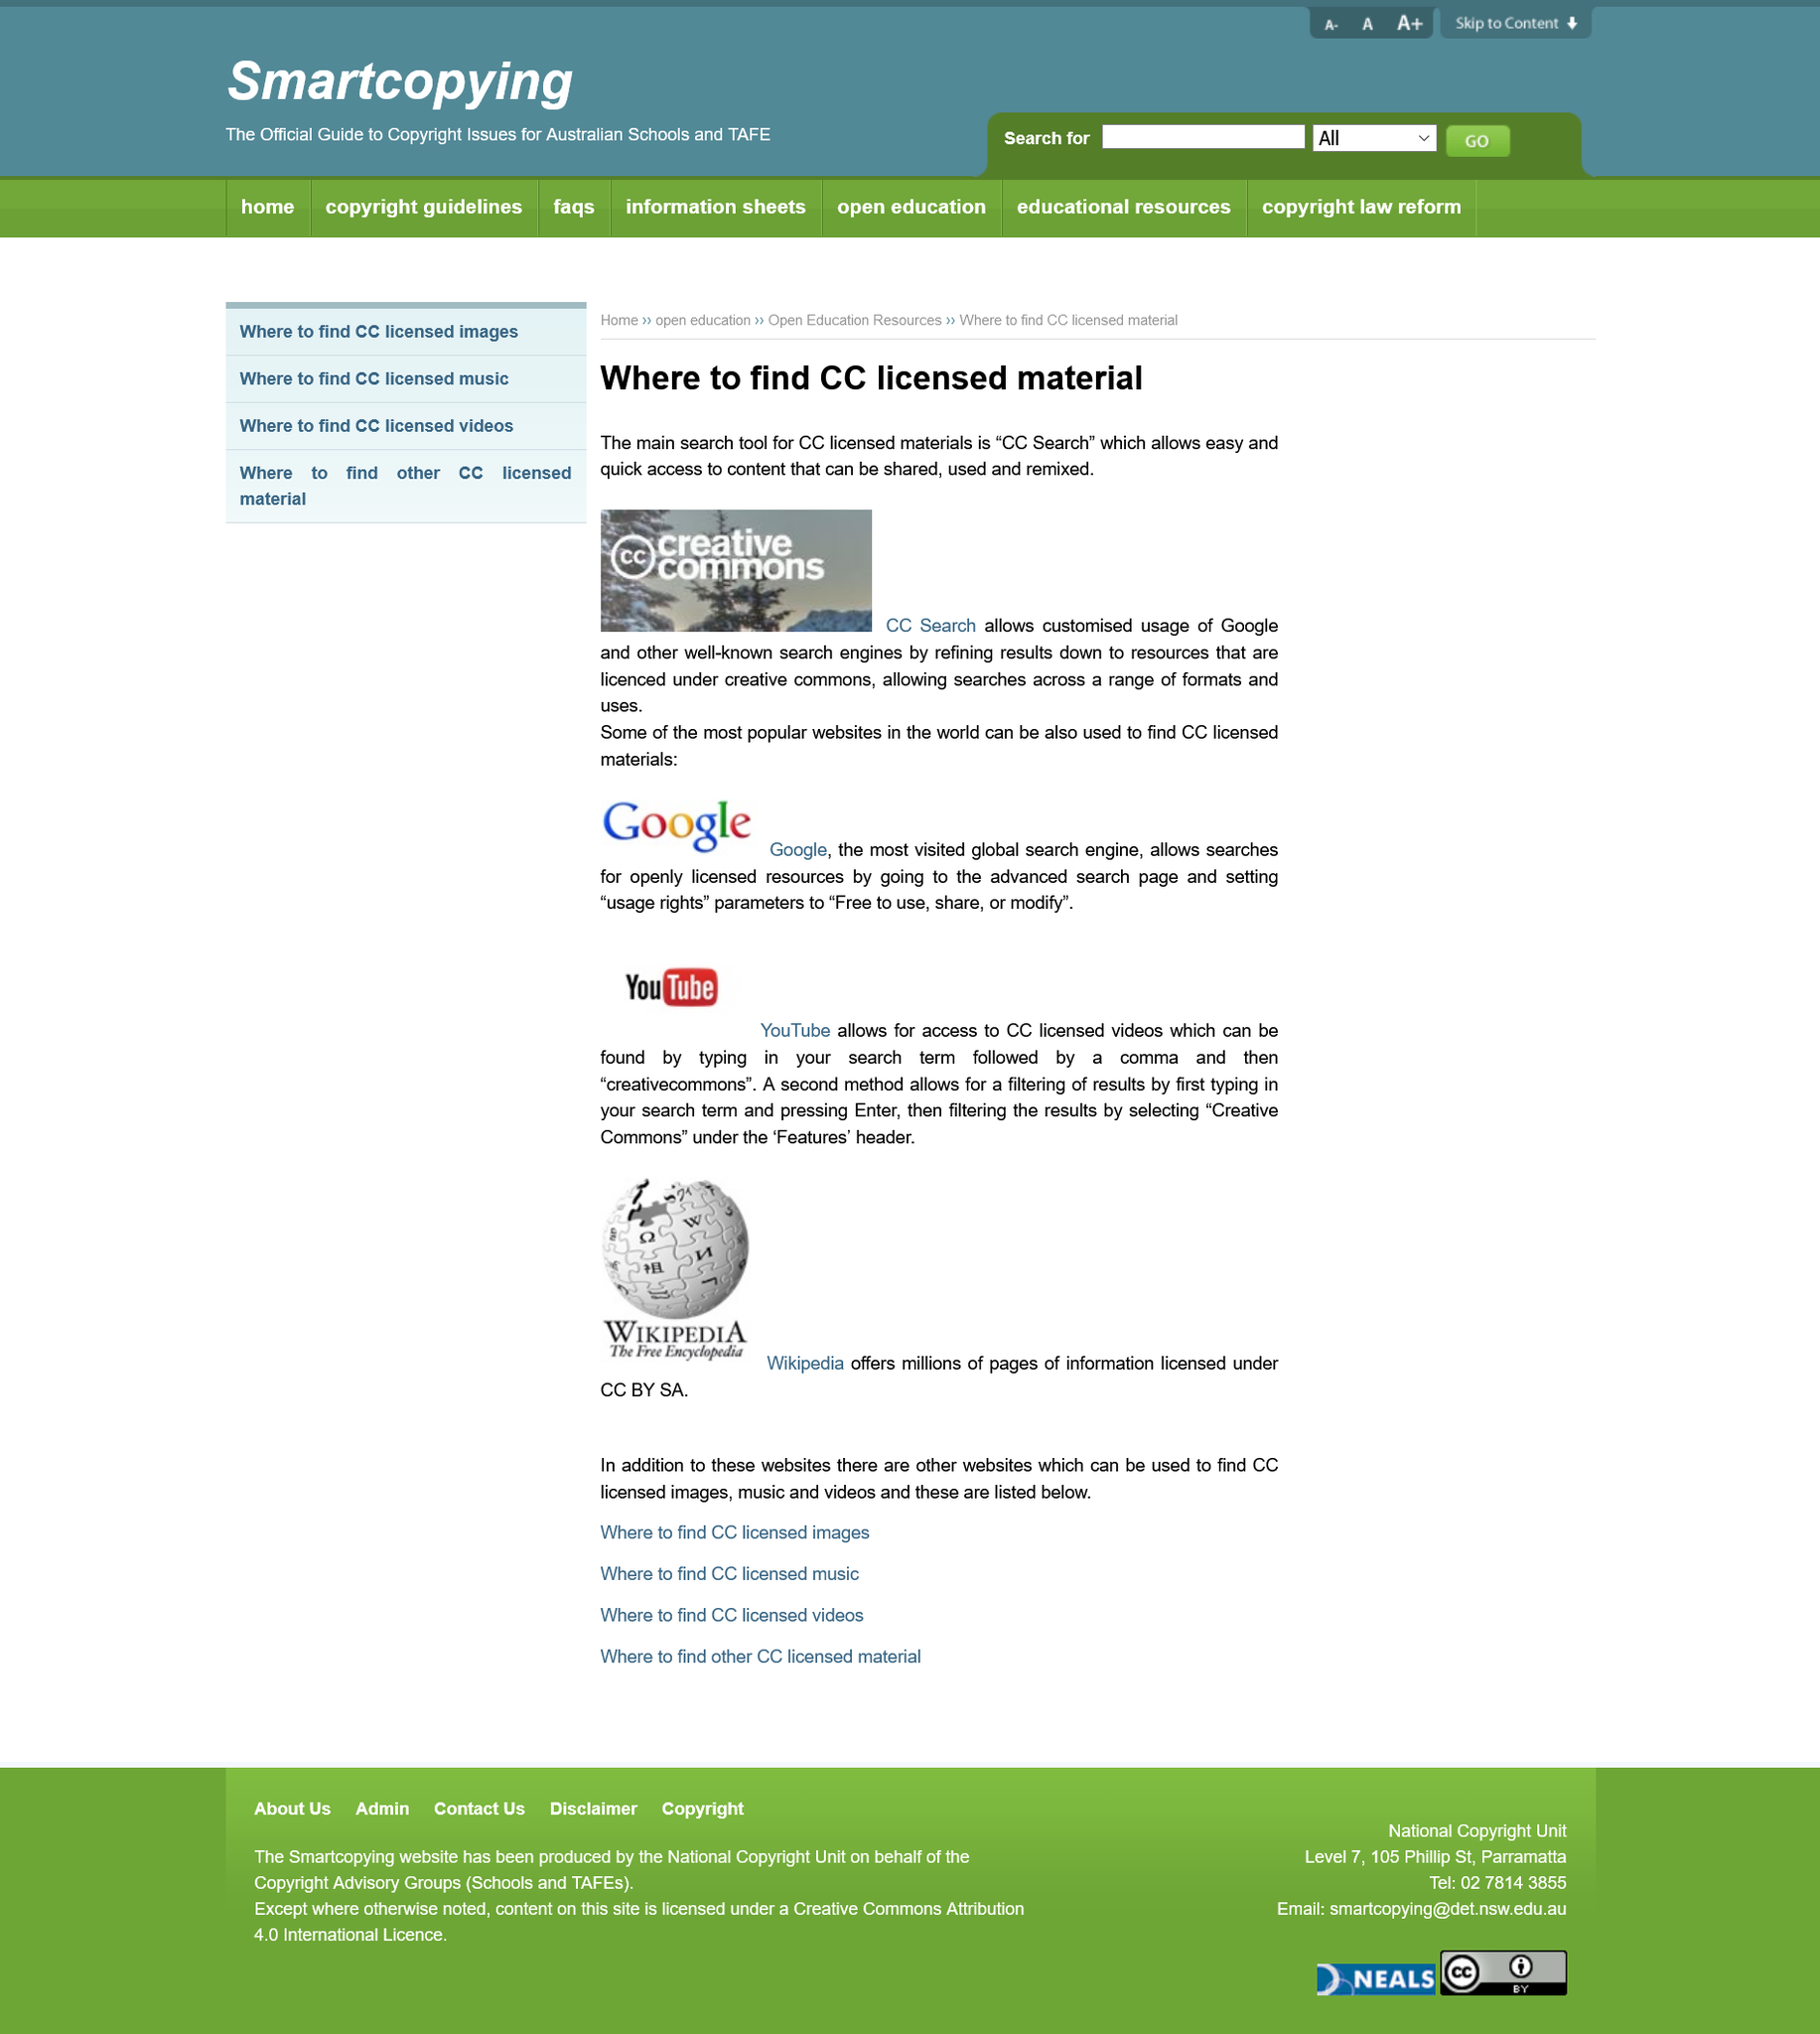Indicate a few pertinent items in this graphic. YouTube and Wikipedia are examples of websites that contain CC licensed images. Yes, there are other websites that use Creative Commons licensed images. You can use the Google CC Search tool to locate content that is licensed under Creative Commons. Google is the most visited global search engine. I am able to search for "CC" on Google. 